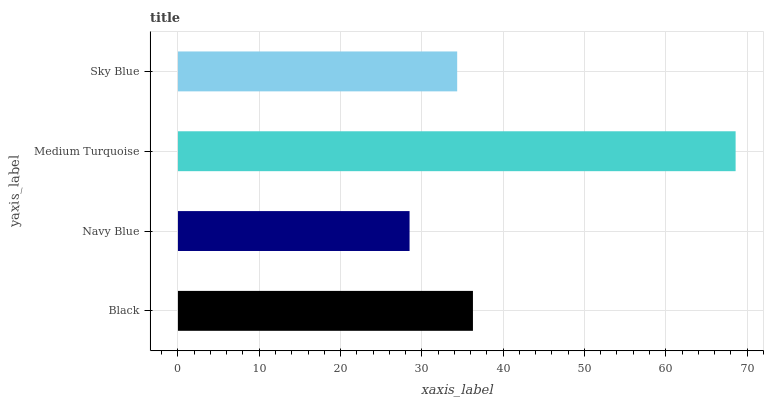Is Navy Blue the minimum?
Answer yes or no. Yes. Is Medium Turquoise the maximum?
Answer yes or no. Yes. Is Medium Turquoise the minimum?
Answer yes or no. No. Is Navy Blue the maximum?
Answer yes or no. No. Is Medium Turquoise greater than Navy Blue?
Answer yes or no. Yes. Is Navy Blue less than Medium Turquoise?
Answer yes or no. Yes. Is Navy Blue greater than Medium Turquoise?
Answer yes or no. No. Is Medium Turquoise less than Navy Blue?
Answer yes or no. No. Is Black the high median?
Answer yes or no. Yes. Is Sky Blue the low median?
Answer yes or no. Yes. Is Navy Blue the high median?
Answer yes or no. No. Is Medium Turquoise the low median?
Answer yes or no. No. 